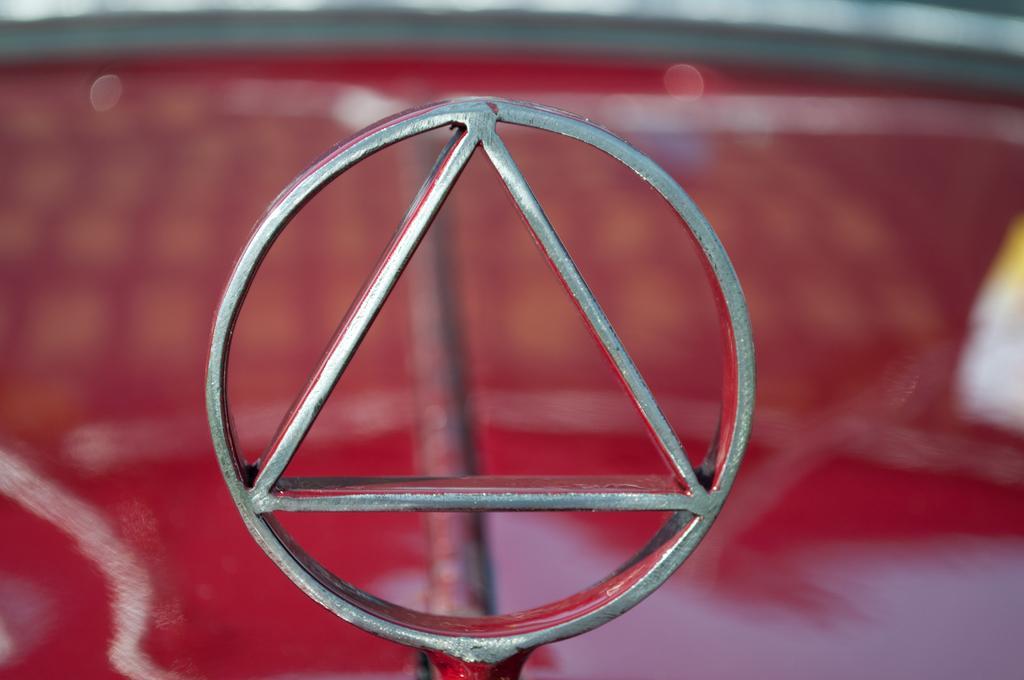Could you give a brief overview of what you see in this image? In this picture we can see a logo, rod and in the background it is blurry. 